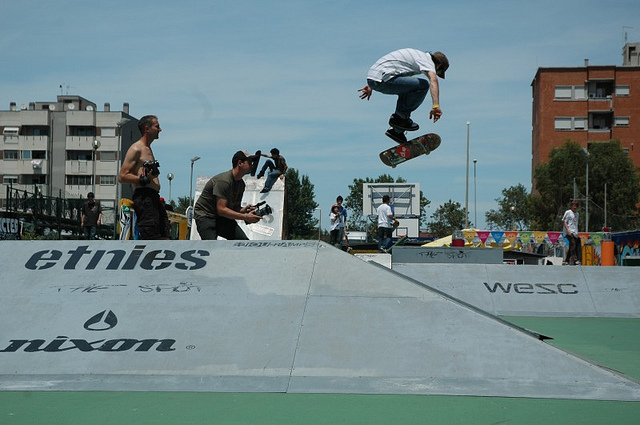<image>Who is recording the skateboarder? It is ambiguous who is recording the skateboarder. It could be a man wearing a cap, a reporter, a friend, or even a camera operator. Who is recording the skateboarder? I am not sure who is recording the skateboarder. It could be the man wearing a cap, the reporter, the person, the man in a plaid shirt, the friend, the man, the friend, the man in a green t-shirt, or the camera operator. 